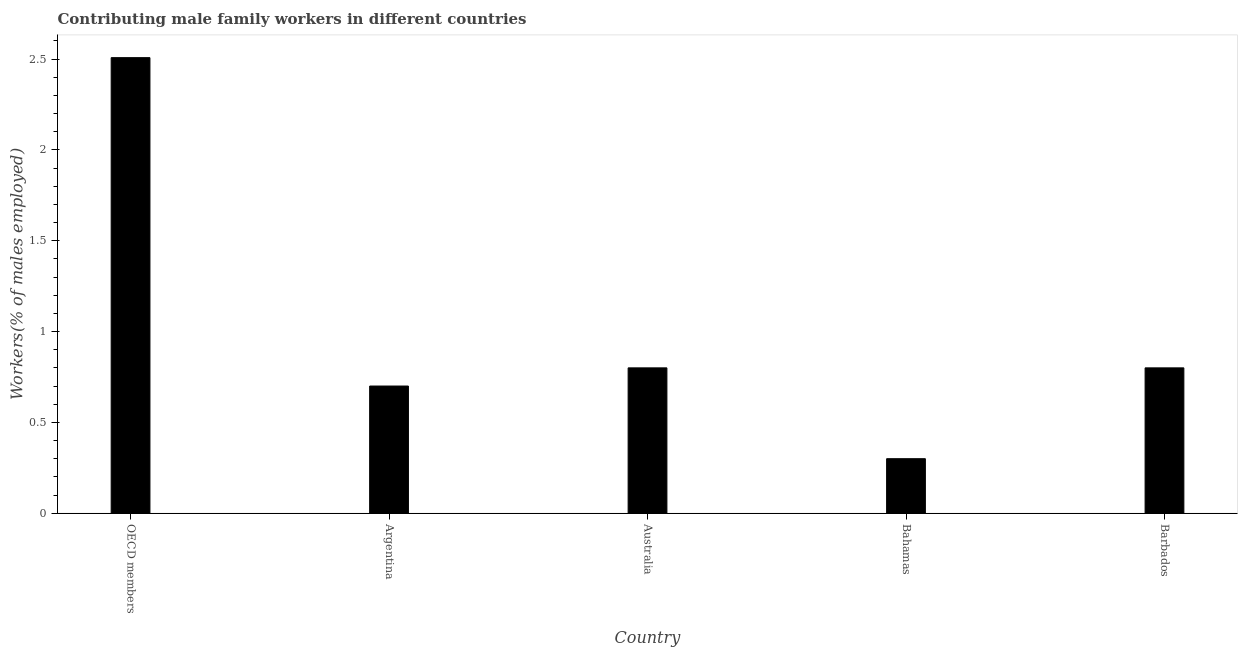Does the graph contain any zero values?
Give a very brief answer. No. Does the graph contain grids?
Offer a terse response. No. What is the title of the graph?
Ensure brevity in your answer.  Contributing male family workers in different countries. What is the label or title of the X-axis?
Provide a succinct answer. Country. What is the label or title of the Y-axis?
Ensure brevity in your answer.  Workers(% of males employed). What is the contributing male family workers in OECD members?
Ensure brevity in your answer.  2.51. Across all countries, what is the maximum contributing male family workers?
Keep it short and to the point. 2.51. Across all countries, what is the minimum contributing male family workers?
Make the answer very short. 0.3. In which country was the contributing male family workers minimum?
Make the answer very short. Bahamas. What is the sum of the contributing male family workers?
Make the answer very short. 5.11. What is the difference between the contributing male family workers in Argentina and Barbados?
Provide a short and direct response. -0.1. What is the median contributing male family workers?
Your answer should be very brief. 0.8. What is the ratio of the contributing male family workers in Argentina to that in Australia?
Offer a terse response. 0.88. Is the contributing male family workers in Argentina less than that in OECD members?
Provide a succinct answer. Yes. Is the difference between the contributing male family workers in Argentina and Barbados greater than the difference between any two countries?
Offer a very short reply. No. What is the difference between the highest and the second highest contributing male family workers?
Give a very brief answer. 1.71. Is the sum of the contributing male family workers in Argentina and Barbados greater than the maximum contributing male family workers across all countries?
Make the answer very short. No. What is the difference between the highest and the lowest contributing male family workers?
Provide a succinct answer. 2.21. How many bars are there?
Make the answer very short. 5. Are all the bars in the graph horizontal?
Ensure brevity in your answer.  No. What is the difference between two consecutive major ticks on the Y-axis?
Provide a short and direct response. 0.5. Are the values on the major ticks of Y-axis written in scientific E-notation?
Your answer should be very brief. No. What is the Workers(% of males employed) of OECD members?
Make the answer very short. 2.51. What is the Workers(% of males employed) of Argentina?
Provide a short and direct response. 0.7. What is the Workers(% of males employed) in Australia?
Make the answer very short. 0.8. What is the Workers(% of males employed) in Bahamas?
Offer a terse response. 0.3. What is the Workers(% of males employed) of Barbados?
Your answer should be compact. 0.8. What is the difference between the Workers(% of males employed) in OECD members and Argentina?
Provide a succinct answer. 1.81. What is the difference between the Workers(% of males employed) in OECD members and Australia?
Your answer should be compact. 1.71. What is the difference between the Workers(% of males employed) in OECD members and Bahamas?
Keep it short and to the point. 2.21. What is the difference between the Workers(% of males employed) in OECD members and Barbados?
Provide a succinct answer. 1.71. What is the difference between the Workers(% of males employed) in Argentina and Bahamas?
Make the answer very short. 0.4. What is the difference between the Workers(% of males employed) in Argentina and Barbados?
Provide a short and direct response. -0.1. What is the difference between the Workers(% of males employed) in Australia and Barbados?
Ensure brevity in your answer.  0. What is the difference between the Workers(% of males employed) in Bahamas and Barbados?
Keep it short and to the point. -0.5. What is the ratio of the Workers(% of males employed) in OECD members to that in Argentina?
Offer a very short reply. 3.58. What is the ratio of the Workers(% of males employed) in OECD members to that in Australia?
Keep it short and to the point. 3.13. What is the ratio of the Workers(% of males employed) in OECD members to that in Bahamas?
Offer a very short reply. 8.36. What is the ratio of the Workers(% of males employed) in OECD members to that in Barbados?
Provide a succinct answer. 3.13. What is the ratio of the Workers(% of males employed) in Argentina to that in Bahamas?
Offer a very short reply. 2.33. What is the ratio of the Workers(% of males employed) in Australia to that in Bahamas?
Offer a terse response. 2.67. 